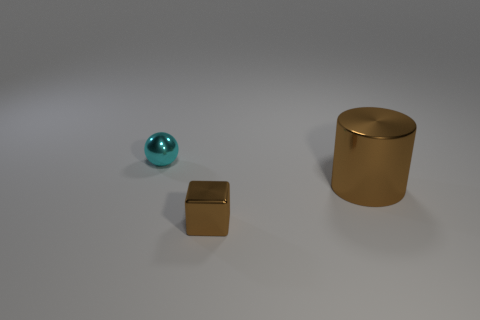The shiny object that is behind the tiny brown object and left of the big brown shiny thing has what shape?
Keep it short and to the point. Sphere. There is a cyan metal sphere; does it have the same size as the brown shiny thing right of the small brown object?
Provide a short and direct response. No. There is a object that is to the left of the small metallic block; is it the same size as the shiny object that is on the right side of the small shiny cube?
Provide a succinct answer. No. What number of objects are either large brown metallic cylinders to the right of the tiny block or large yellow rubber objects?
Your answer should be compact. 1. Is there a red thing that has the same shape as the big brown metal thing?
Your response must be concise. No. Are there the same number of shiny balls that are in front of the metal cube and brown cylinders?
Offer a very short reply. No. What is the shape of the small metallic thing that is the same color as the large shiny object?
Offer a very short reply. Cube. How many cyan balls have the same size as the shiny cylinder?
Your answer should be very brief. 0. What number of metallic cylinders are in front of the cyan metallic object?
Provide a short and direct response. 1. Are there any small blocks that have the same color as the large metal object?
Offer a very short reply. Yes. 